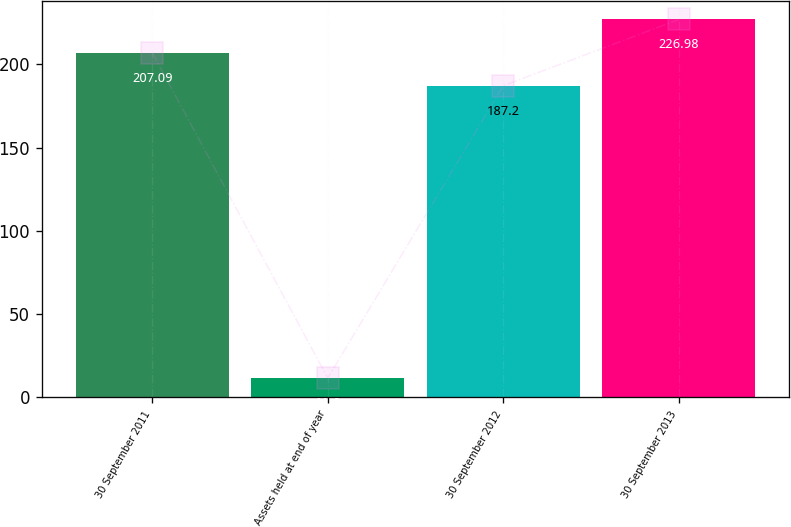Convert chart. <chart><loc_0><loc_0><loc_500><loc_500><bar_chart><fcel>30 September 2011<fcel>Assets held at end of year<fcel>30 September 2012<fcel>30 September 2013<nl><fcel>207.09<fcel>11.6<fcel>187.2<fcel>226.98<nl></chart> 